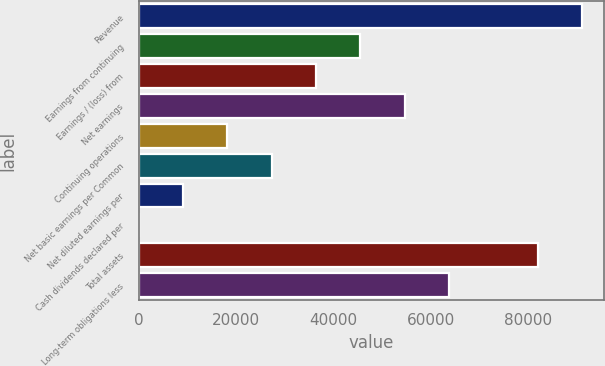Convert chart to OTSL. <chart><loc_0><loc_0><loc_500><loc_500><bar_chart><fcel>Revenue<fcel>Earnings from continuing<fcel>Earnings / (loss) from<fcel>Net earnings<fcel>Continuing operations<fcel>Net basic earnings per Common<fcel>Net diluted earnings per<fcel>Cash dividends declared per<fcel>Total assets<fcel>Long-term obligations less<nl><fcel>90975.5<fcel>45488<fcel>36390.5<fcel>54585.5<fcel>18195.5<fcel>27293<fcel>9098<fcel>0.5<fcel>81878<fcel>63683<nl></chart> 